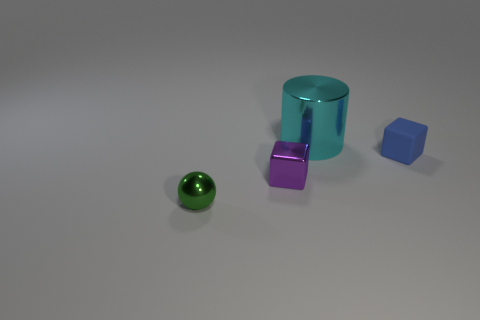Add 3 tiny green balls. How many objects exist? 7 Subtract all spheres. How many objects are left? 3 Subtract all blue blocks. How many blocks are left? 1 Add 1 small rubber things. How many small rubber things exist? 2 Subtract 0 brown cubes. How many objects are left? 4 Subtract all purple blocks. Subtract all purple balls. How many blocks are left? 1 Subtract all brown rubber things. Subtract all small blocks. How many objects are left? 2 Add 3 balls. How many balls are left? 4 